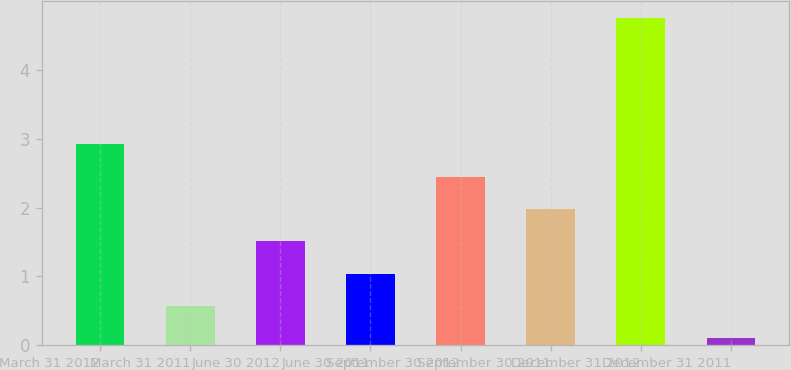<chart> <loc_0><loc_0><loc_500><loc_500><bar_chart><fcel>March 31 2012<fcel>March 31 2011<fcel>June 30 2012<fcel>June 30 2011<fcel>September 30 2012<fcel>September 30 2011<fcel>December 31 2012<fcel>December 31 2011<nl><fcel>2.92<fcel>0.57<fcel>1.51<fcel>1.04<fcel>2.45<fcel>1.98<fcel>4.76<fcel>0.1<nl></chart> 